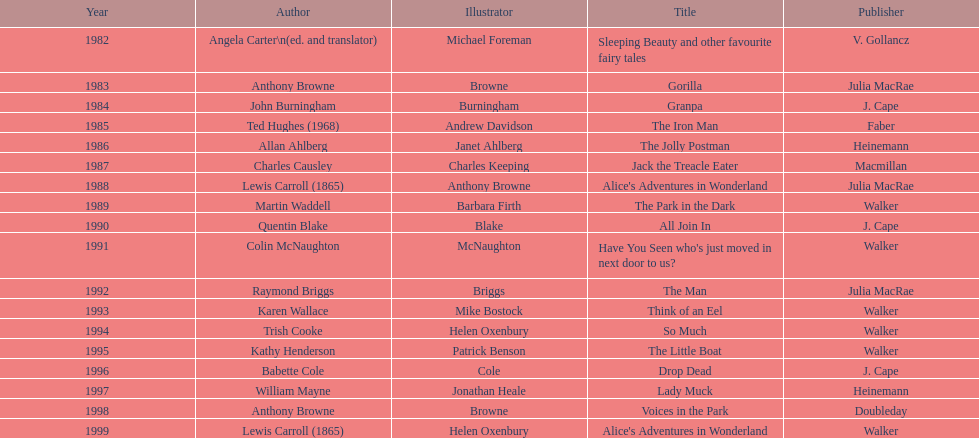Which book received the award twice in total? Alice's Adventures in Wonderland. 